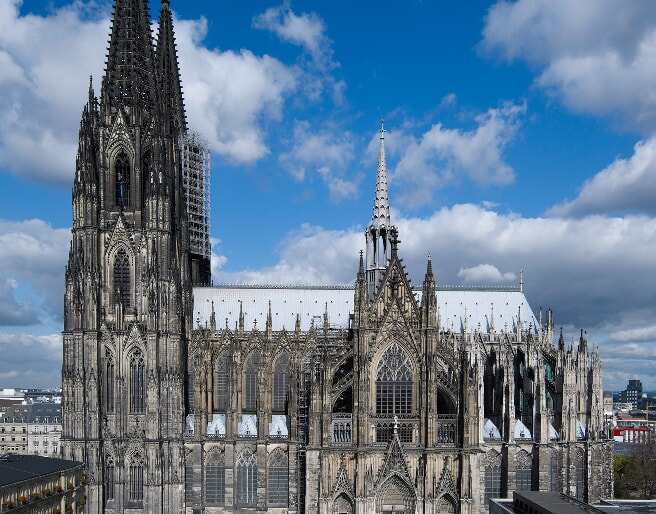Analyze the image in a comprehensive and detailed manner. The image prominently features Cologne Cathedral, a masterpiece of Gothic architecture, located in Cologne, Germany. This imposing structure is renowned for its formidable towers and delicate flying buttresses which support its tall, sky-reaching spires. The stonework exhibits exquisite detailing typical of Gothic design, including pointed arches and ribbed vaults. The cathedral, a UNESCO World Heritage Site, is not only a testament to the architectural advancements of its time but also encompasses centuries of history, having survived numerous renovations and World War II damages. Its position against the clear blue sky highlights its majestic outline and the painstaking craftsmanship of each sculpted stone and stained glass window visible from this wide-angle perspective. 